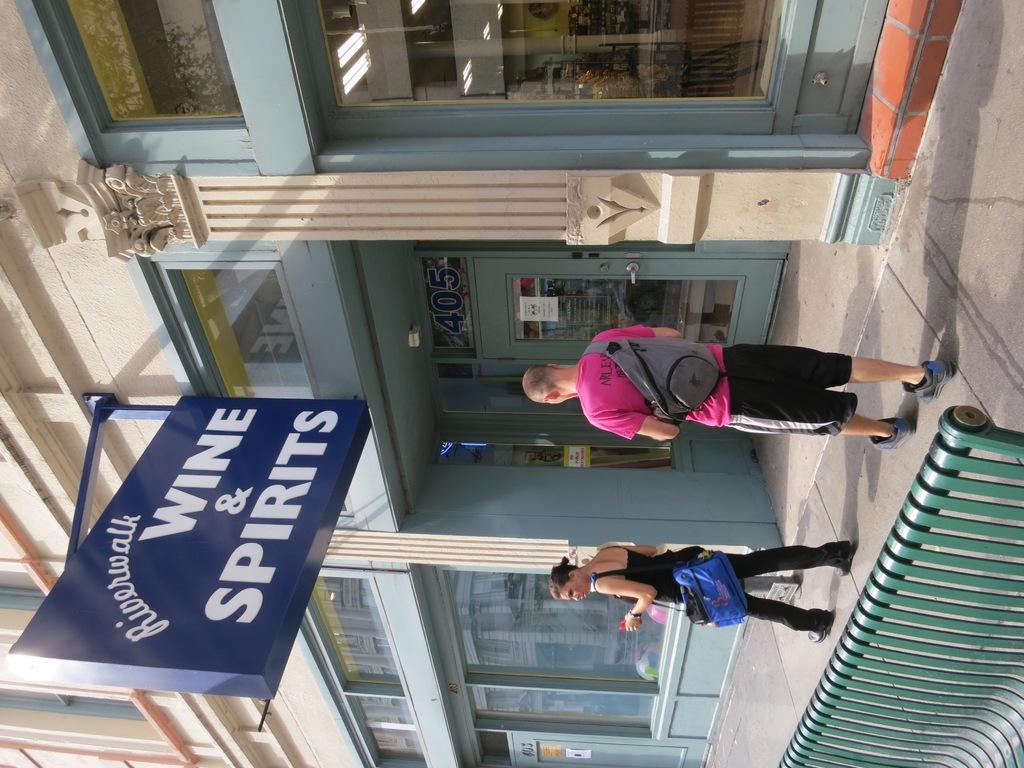What are the people in the image doing? People are walking on the pavement in the image. What can be found on the pavement besides people? There is a bench on the pavement. What are the people carrying? The people are carrying bags. What is attached to the wall of a building in the image? A board is attached to the wall of a building. What is written or displayed on the board? There is text on the board. What type of brass instrument can be seen being played on the hill in the image? There is no brass instrument or hill present in the image; it features people walking on a pavement with a bench and a board with text. 